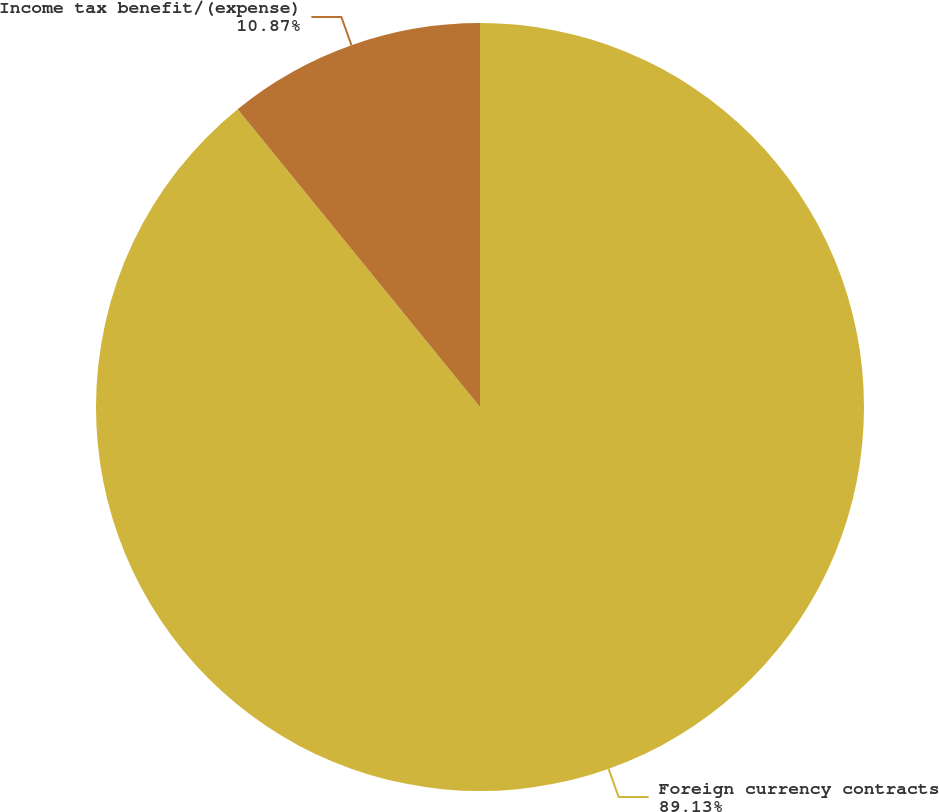Convert chart to OTSL. <chart><loc_0><loc_0><loc_500><loc_500><pie_chart><fcel>Foreign currency contracts<fcel>Income tax benefit/(expense)<nl><fcel>89.13%<fcel>10.87%<nl></chart> 